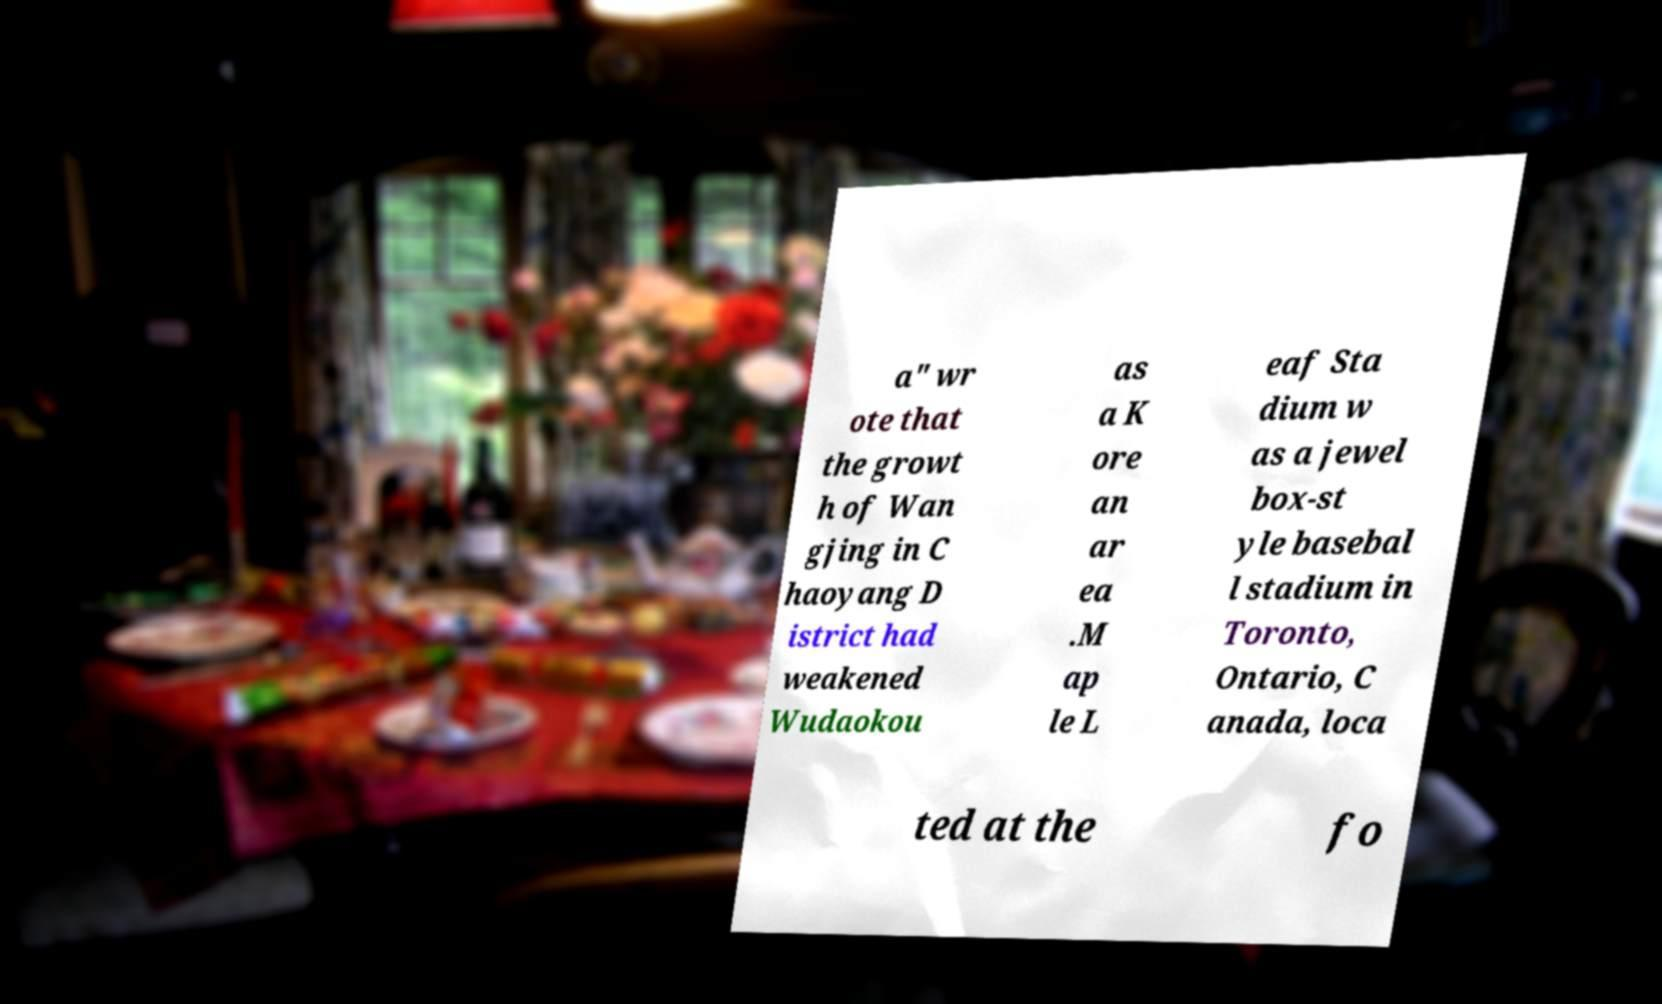There's text embedded in this image that I need extracted. Can you transcribe it verbatim? a" wr ote that the growt h of Wan gjing in C haoyang D istrict had weakened Wudaokou as a K ore an ar ea .M ap le L eaf Sta dium w as a jewel box-st yle basebal l stadium in Toronto, Ontario, C anada, loca ted at the fo 